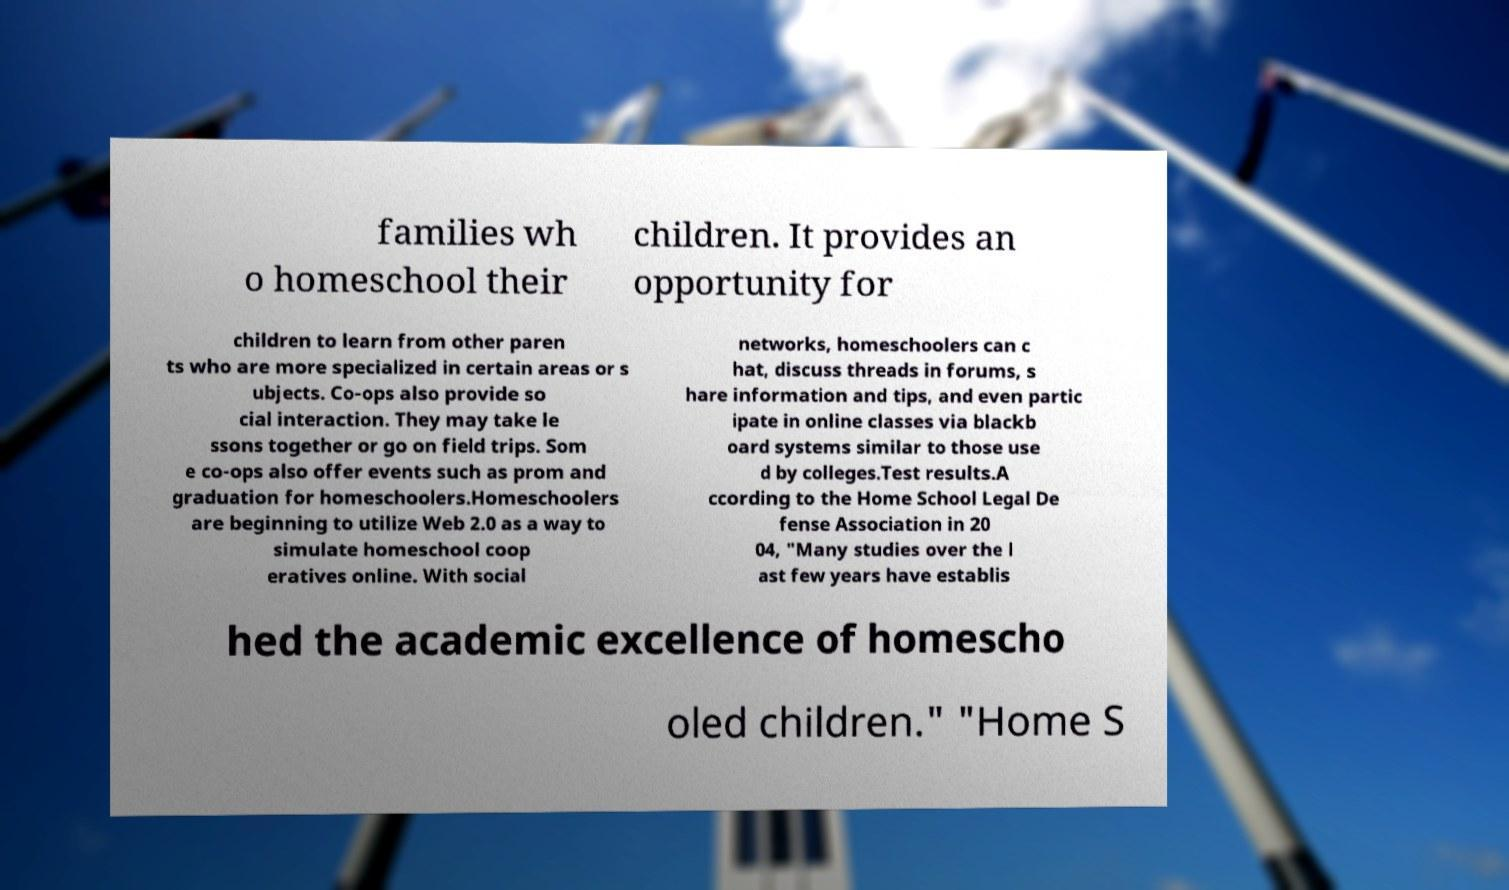For documentation purposes, I need the text within this image transcribed. Could you provide that? families wh o homeschool their children. It provides an opportunity for children to learn from other paren ts who are more specialized in certain areas or s ubjects. Co-ops also provide so cial interaction. They may take le ssons together or go on field trips. Som e co-ops also offer events such as prom and graduation for homeschoolers.Homeschoolers are beginning to utilize Web 2.0 as a way to simulate homeschool coop eratives online. With social networks, homeschoolers can c hat, discuss threads in forums, s hare information and tips, and even partic ipate in online classes via blackb oard systems similar to those use d by colleges.Test results.A ccording to the Home School Legal De fense Association in 20 04, "Many studies over the l ast few years have establis hed the academic excellence of homescho oled children." "Home S 